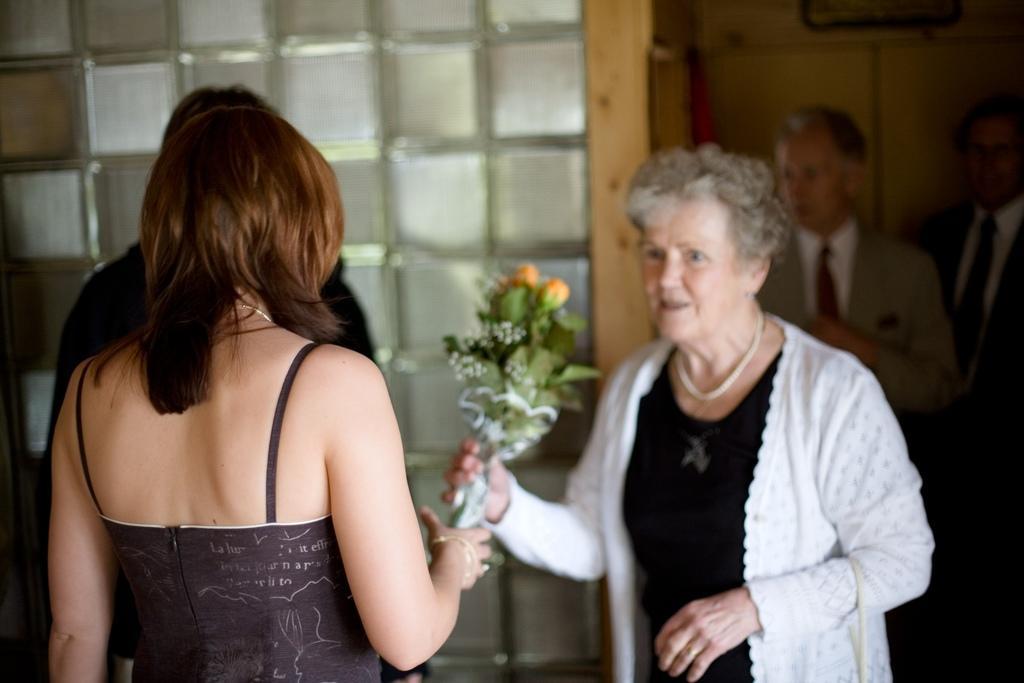How would you summarize this image in a sentence or two? In the foreground of the image there are two ladies, one lady is holding a bouquet in her hand. In the background of the image there are people. There is a wall. There is a glass design. 